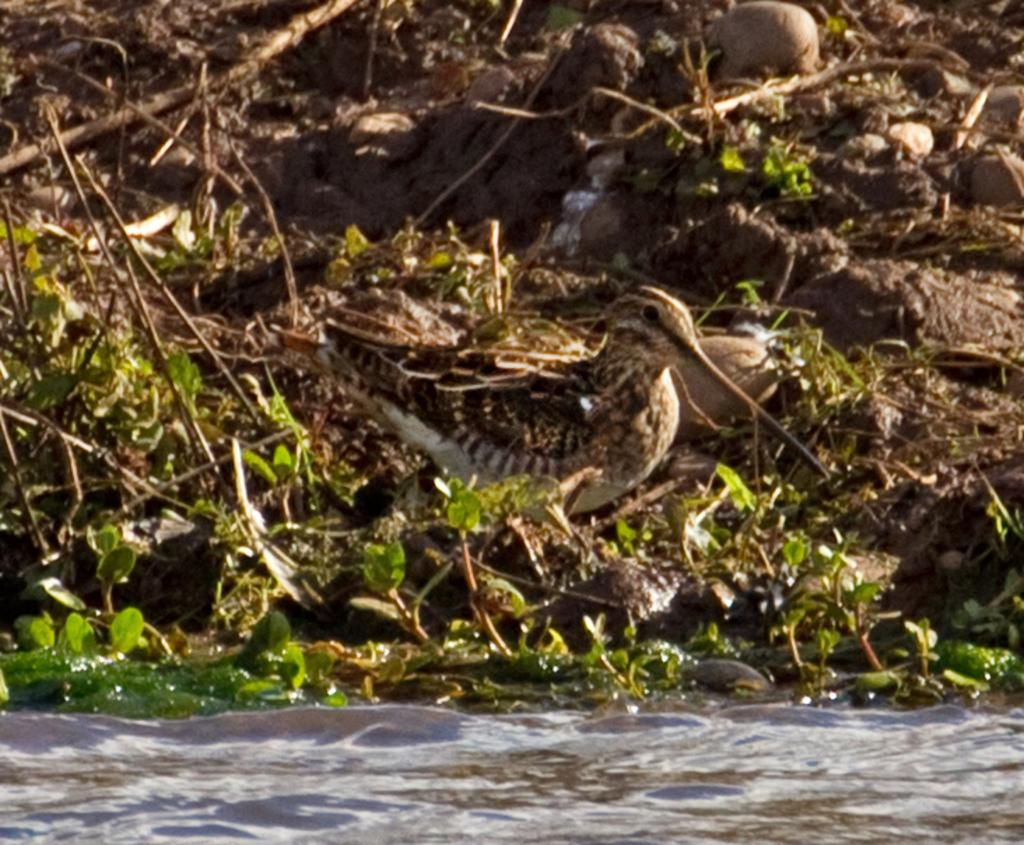What type of animal can be seen in the image? There is a bird with a long beak in the image. Where is the bird located in the image? The bird is standing on the ground. What can be seen in the foreground of the image? There is water and plants visible in the foreground of the image. What is the price of the club that the bird is holding in the image? There is no club present in the image, and therefore no price can be determined. 